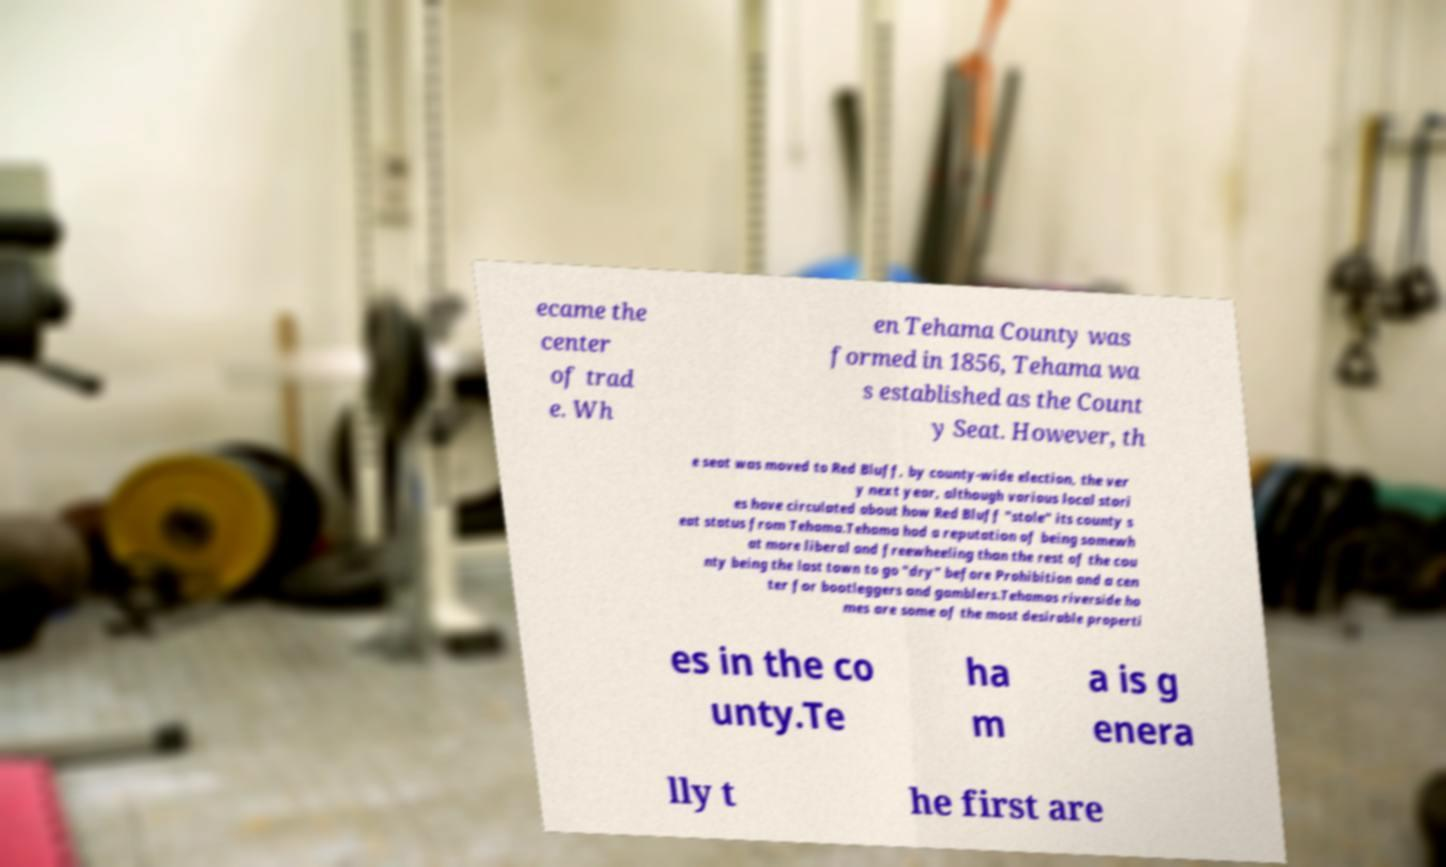Please identify and transcribe the text found in this image. ecame the center of trad e. Wh en Tehama County was formed in 1856, Tehama wa s established as the Count y Seat. However, th e seat was moved to Red Bluff, by county-wide election, the ver y next year, although various local stori es have circulated about how Red Bluff "stole" its county s eat status from Tehama.Tehama had a reputation of being somewh at more liberal and freewheeling than the rest of the cou nty being the last town to go "dry" before Prohibition and a cen ter for bootleggers and gamblers.Tehamas riverside ho mes are some of the most desirable properti es in the co unty.Te ha m a is g enera lly t he first are 